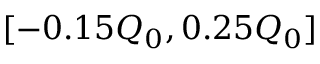<formula> <loc_0><loc_0><loc_500><loc_500>[ - 0 . 1 5 Q _ { 0 } , 0 . 2 5 Q _ { 0 } ]</formula> 